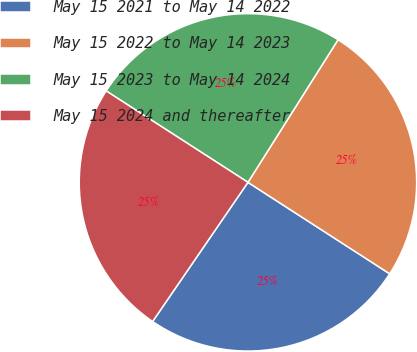Convert chart. <chart><loc_0><loc_0><loc_500><loc_500><pie_chart><fcel>May 15 2021 to May 14 2022<fcel>May 15 2022 to May 14 2023<fcel>May 15 2023 to May 14 2024<fcel>May 15 2024 and thereafter<nl><fcel>25.44%<fcel>25.15%<fcel>24.85%<fcel>24.55%<nl></chart> 